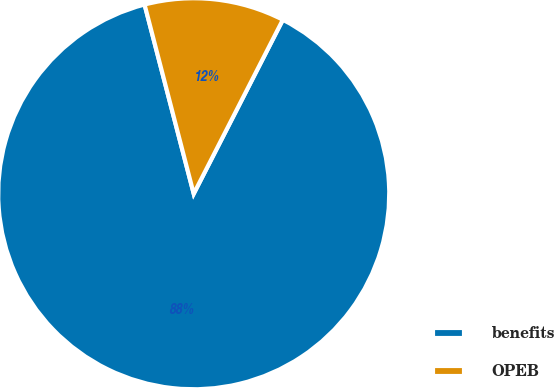Convert chart. <chart><loc_0><loc_0><loc_500><loc_500><pie_chart><fcel>benefits<fcel>OPEB<nl><fcel>88.42%<fcel>11.58%<nl></chart> 